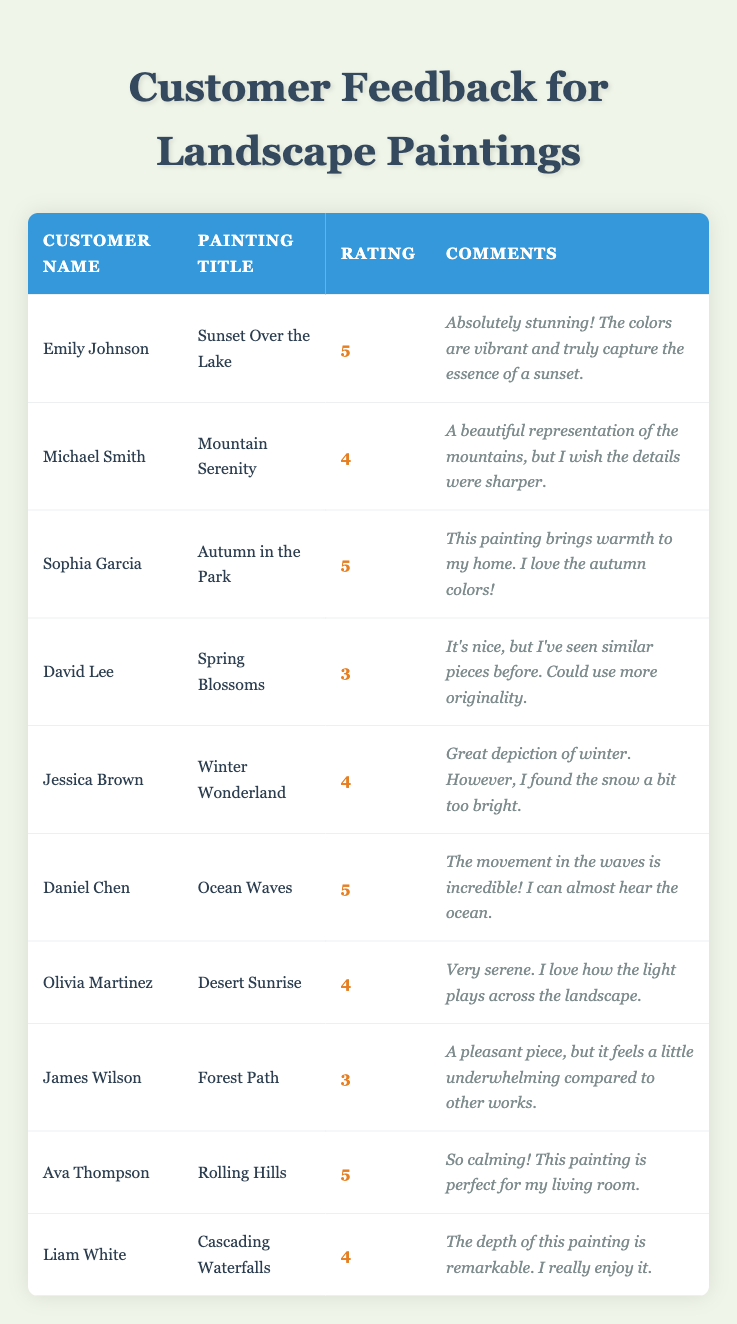What is the highest rating given to a painting? The highest rating in the table is 5, given to "Sunset Over the Lake," "Autumn in the Park," "Ocean Waves," and "Rolling Hills."
Answer: 5 How many paintings received a rating of 4? There are four paintings with a rating of 4: "Mountain Serenity," "Winter Wonderland," "Desert Sunrise," and "Cascading Waterfalls."
Answer: 4 Is there a painting rated 3? Yes, "Spring Blossoms" and "Forest Path" both received a rating of 3.
Answer: Yes What is the average rating of all the paintings? The sum of all the ratings (5 + 4 + 5 + 3 + 4 + 5 + 4 + 3 + 5 + 4) = 46, and there are 10 paintings, so the average is 46/10 = 4.6.
Answer: 4.6 Which customer gave the comments noted as "A beautiful representation of the mountains, but I wish the details were sharper."? That comment was provided by Michael Smith for the painting "Mountain Serenity."
Answer: Michael Smith What is the total number of ratings for paintings scored below 4? The paintings with ratings below 4 are "Spring Blossoms" and "Forest Path," each scored 3. The total number of ratings below 4 is 2.
Answer: 2 Which painting was rated lowest and what was the rating? The lowest rating is 3, given to both "Spring Blossoms" and "Forest Path."
Answer: 3 How many customers enjoyed the colors in their purchased painting? Customers who appreciated the colors include Emily Johnson, Sophia Garcia, Daniel Chen, and Ava Thompson, totaling 4 customers.
Answer: 4 What percentage of the paintings received a rating of 5? There are 10 paintings total, and 4 received a rating of 5. Therefore, the percentage is (4/10) * 100 = 40%.
Answer: 40% Which painting received comments about being "calming" and who provided that feedback? "Rolling Hills" received comments about being calming from Ava Thompson.
Answer: Rolling Hills, Ava Thompson 